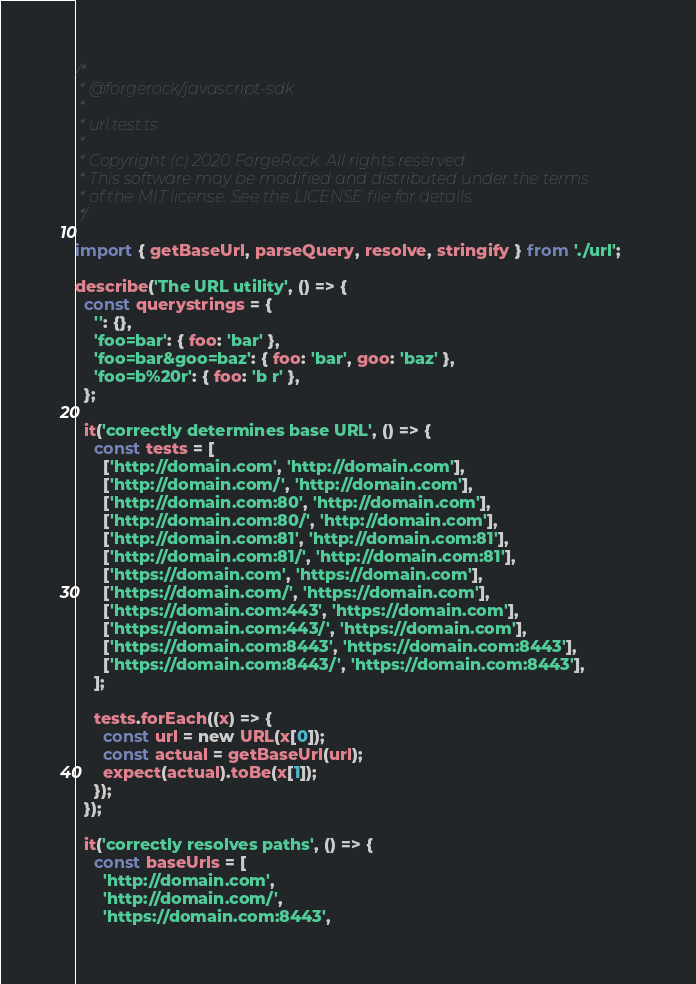Convert code to text. <code><loc_0><loc_0><loc_500><loc_500><_TypeScript_>/*
 * @forgerock/javascript-sdk
 *
 * url.test.ts
 *
 * Copyright (c) 2020 ForgeRock. All rights reserved.
 * This software may be modified and distributed under the terms
 * of the MIT license. See the LICENSE file for details.
 */

import { getBaseUrl, parseQuery, resolve, stringify } from './url';

describe('The URL utility', () => {
  const querystrings = {
    '': {},
    'foo=bar': { foo: 'bar' },
    'foo=bar&goo=baz': { foo: 'bar', goo: 'baz' },
    'foo=b%20r': { foo: 'b r' },
  };

  it('correctly determines base URL', () => {
    const tests = [
      ['http://domain.com', 'http://domain.com'],
      ['http://domain.com/', 'http://domain.com'],
      ['http://domain.com:80', 'http://domain.com'],
      ['http://domain.com:80/', 'http://domain.com'],
      ['http://domain.com:81', 'http://domain.com:81'],
      ['http://domain.com:81/', 'http://domain.com:81'],
      ['https://domain.com', 'https://domain.com'],
      ['https://domain.com/', 'https://domain.com'],
      ['https://domain.com:443', 'https://domain.com'],
      ['https://domain.com:443/', 'https://domain.com'],
      ['https://domain.com:8443', 'https://domain.com:8443'],
      ['https://domain.com:8443/', 'https://domain.com:8443'],
    ];

    tests.forEach((x) => {
      const url = new URL(x[0]);
      const actual = getBaseUrl(url);
      expect(actual).toBe(x[1]);
    });
  });

  it('correctly resolves paths', () => {
    const baseUrls = [
      'http://domain.com',
      'http://domain.com/',
      'https://domain.com:8443',</code> 